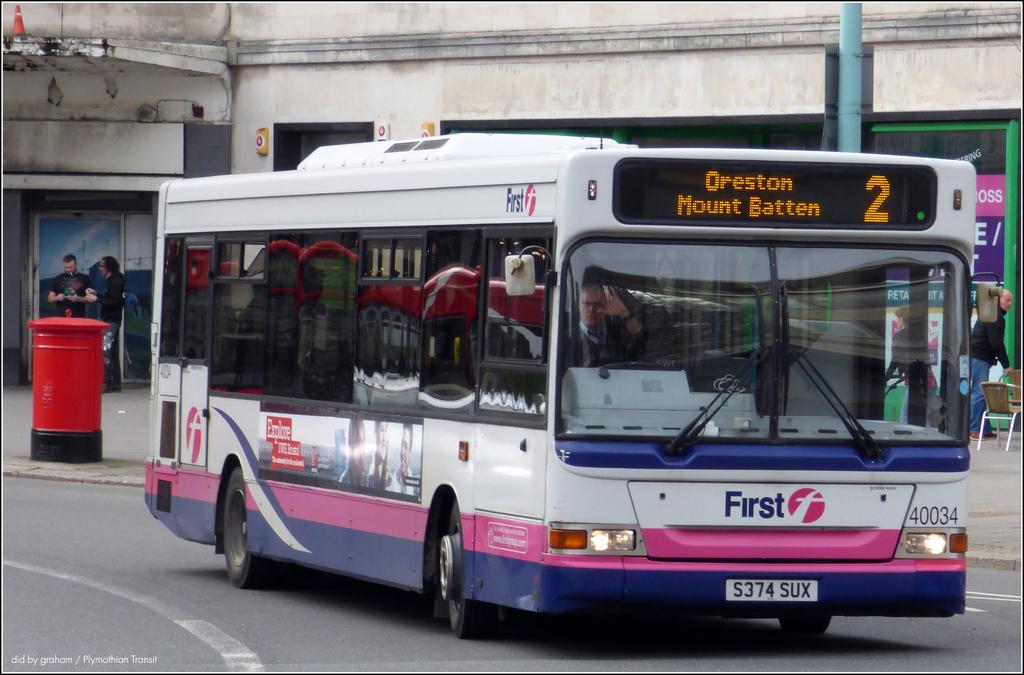What number bus line is this?
Your response must be concise. 2. Is this a passenger bus?
Your response must be concise. Yes. 